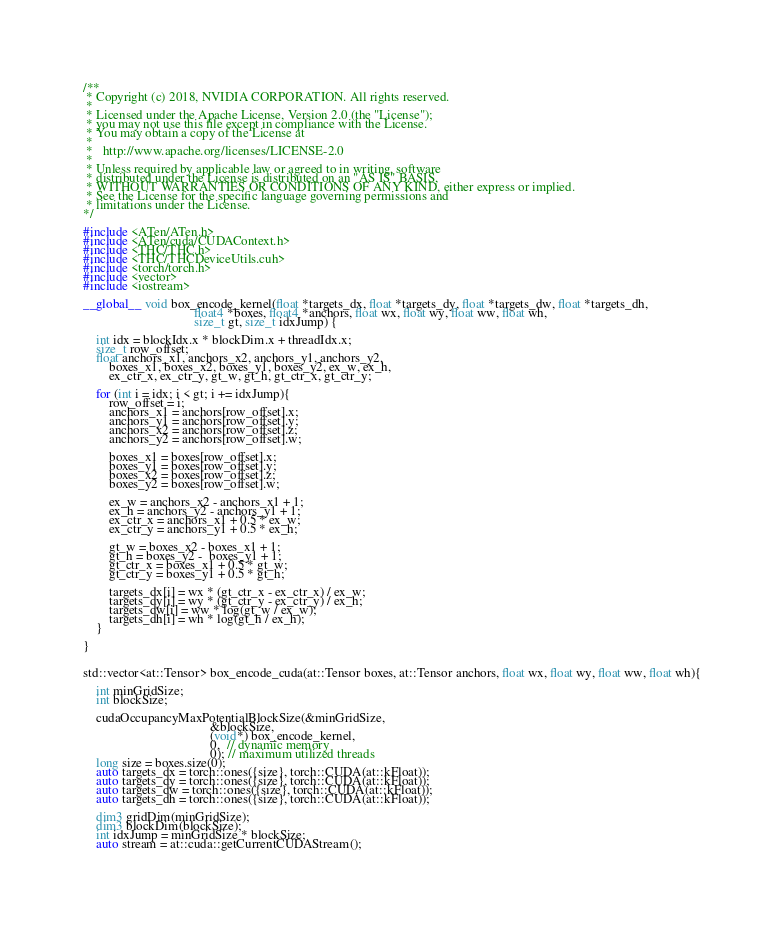Convert code to text. <code><loc_0><loc_0><loc_500><loc_500><_Cuda_>/**
 * Copyright (c) 2018, NVIDIA CORPORATION. All rights reserved.
 *
 * Licensed under the Apache License, Version 2.0 (the "License");
 * you may not use this file except in compliance with the License.
 * You may obtain a copy of the License at
 *
 *   http://www.apache.org/licenses/LICENSE-2.0
 *
 * Unless required by applicable law or agreed to in writing, software
 * distributed under the License is distributed on an "AS IS" BASIS,
 * WITHOUT WARRANTIES OR CONDITIONS OF ANY KIND, either express or implied.
 * See the License for the specific language governing permissions and
 * limitations under the License.
*/

#include <ATen/ATen.h>
#include <ATen/cuda/CUDAContext.h>
#include <THC/THC.h>
#include <THC/THCDeviceUtils.cuh>
#include <torch/torch.h>
#include <vector>
#include <iostream>

__global__ void box_encode_kernel(float *targets_dx, float *targets_dy, float *targets_dw, float *targets_dh,  
                                  float4 *boxes, float4 *anchors, float wx, float wy, float ww, float wh, 
                                  size_t gt, size_t idxJump) {

    int idx = blockIdx.x * blockDim.x + threadIdx.x;
    size_t row_offset; 
    float anchors_x1, anchors_x2, anchors_y1, anchors_y2, 
        boxes_x1, boxes_x2, boxes_y1, boxes_y2, ex_w, ex_h, 
        ex_ctr_x, ex_ctr_y, gt_w, gt_h, gt_ctr_x, gt_ctr_y;
          
    for (int i = idx; i < gt; i += idxJump){
        row_offset = i;
        anchors_x1 = anchors[row_offset].x;
        anchors_y1 = anchors[row_offset].y;
        anchors_x2 = anchors[row_offset].z;
        anchors_y2 = anchors[row_offset].w;        

        boxes_x1 = boxes[row_offset].x;
        boxes_y1 = boxes[row_offset].y;
        boxes_x2 = boxes[row_offset].z;
        boxes_y2 = boxes[row_offset].w; 
        
        ex_w = anchors_x2 - anchors_x1 + 1;
        ex_h = anchors_y2 - anchors_y1 + 1;
        ex_ctr_x = anchors_x1 + 0.5 * ex_w; 
        ex_ctr_y = anchors_y1 + 0.5 * ex_h;
               
        gt_w = boxes_x2 - boxes_x1 + 1;
        gt_h = boxes_y2 -  boxes_y1 + 1; 
        gt_ctr_x = boxes_x1 + 0.5 * gt_w; 
        gt_ctr_y = boxes_y1 + 0.5 * gt_h;        
        
        targets_dx[i] = wx * (gt_ctr_x - ex_ctr_x) / ex_w; 
        targets_dy[i] = wy * (gt_ctr_y - ex_ctr_y) / ex_h; 
        targets_dw[i] = ww * log(gt_w / ex_w); 
        targets_dh[i] = wh * log(gt_h / ex_h);          
    }  

}


std::vector<at::Tensor> box_encode_cuda(at::Tensor boxes, at::Tensor anchors, float wx, float wy, float ww, float wh){
   
    int minGridSize;
    int blockSize;
    
    cudaOccupancyMaxPotentialBlockSize(&minGridSize,
                                       &blockSize,
                                       (void*) box_encode_kernel,
                                       0,  // dynamic memory
                                       0); // maximum utilized threads    
    long size = boxes.size(0);
    auto targets_dx = torch::ones({size}, torch::CUDA(at::kFloat)); 
    auto targets_dy = torch::ones({size}, torch::CUDA(at::kFloat));
    auto targets_dw = torch::ones({size}, torch::CUDA(at::kFloat));
    auto targets_dh = torch::ones({size}, torch::CUDA(at::kFloat));
    
    dim3 gridDim(minGridSize);
    dim3 blockDim(blockSize);
    int idxJump = minGridSize * blockSize;
    auto stream = at::cuda::getCurrentCUDAStream();</code> 